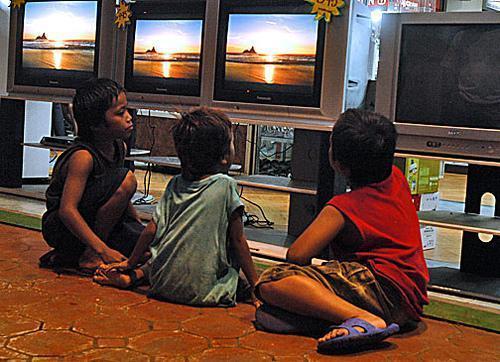How many boys are there?
Give a very brief answer. 3. How many TVs are in?
Give a very brief answer. 3. How many tvs are in the photo?
Give a very brief answer. 4. How many people are in the photo?
Give a very brief answer. 3. 